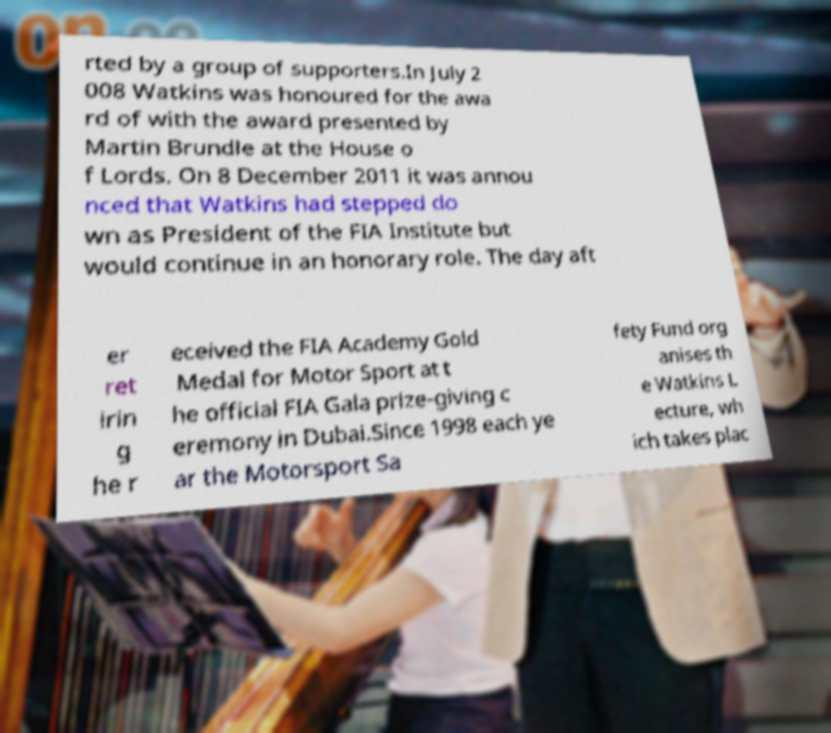Can you read and provide the text displayed in the image?This photo seems to have some interesting text. Can you extract and type it out for me? rted by a group of supporters.In July 2 008 Watkins was honoured for the awa rd of with the award presented by Martin Brundle at the House o f Lords. On 8 December 2011 it was annou nced that Watkins had stepped do wn as President of the FIA Institute but would continue in an honorary role. The day aft er ret irin g he r eceived the FIA Academy Gold Medal for Motor Sport at t he official FIA Gala prize-giving c eremony in Dubai.Since 1998 each ye ar the Motorsport Sa fety Fund org anises th e Watkins L ecture, wh ich takes plac 